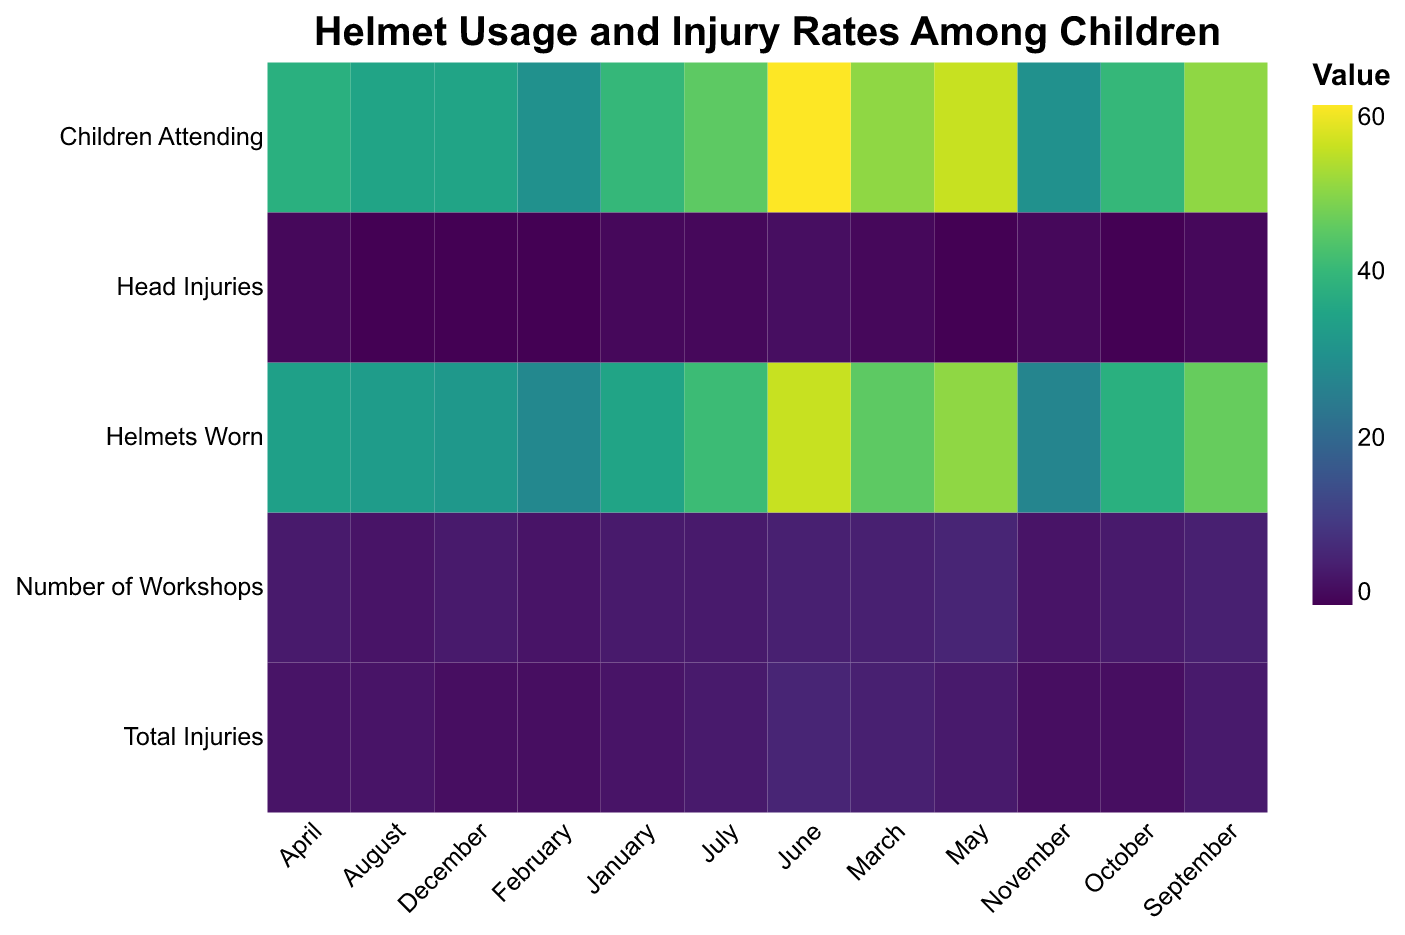How many children wore helmets in March? Locate the data point for "Helmets Worn" in the March column. The corresponding value is 45.
Answer: 45 Which month had the highest number of head injuries? Scan the "Head Injuries" row for the highest value. June has the highest value with 2 head injuries.
Answer: June What is the total number of injuries in February? Locate the data point for "Total Injuries" in the February column. The corresponding value is 2.
Answer: 2 Compare the number of workshops held in January and May. Which month had more? The "Number of Workshops" for January is 4 and for May is 6. Comparing these, May had more workshops.
Answer: May What's the average number of helmets worn per month? Sum the values in the "Helmets Worn" row and divide by the number of months: (35 + 28 + 45 + 34 + 50 + 55 + 41 + 33 + 46 + 38 + 27 + 32 ) / 12 = 464 / 12 ≈ 38.67
Answer: 38.67 In which months were there zero head injuries? Locate the data points in the "Head Injuries" row where the value is 0. These months are February, May, August, October, and December.
Answer: February, May, August, October, December Compare the total injuries in the months of April and July. Which month had fewer injuries? The "Total Injuries" for April is 3 and for July is 4. April had fewer injuries.
Answer: April What is the median number of children attending workshops each month? Arrange the "Children Attending" values in ascending order: 30, 30, 35, 35, 38, 40, 40, 45, 50, 50, 55, 60. The median is the average of the middle two numbers (40+40)/2 = 40.
Answer: 40 Which month had the highest attendance of children, and how many attended? Locate the highest value in the "Children Attending" row. The highest value is in June with 60 children attending.
Answer: June, 60 What is the percentage of children wearing helmets in June? Divide the number of "Helmets Worn" in June by the "Children Attending" in June and multiply by 100: (55/60) * 100 ≈ 91.67%.
Answer: 91.67% 